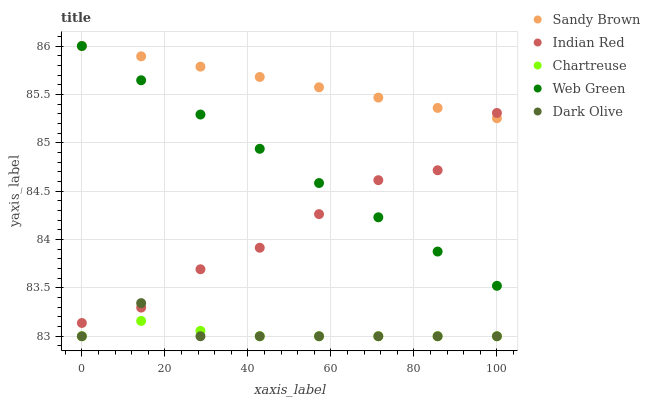Does Chartreuse have the minimum area under the curve?
Answer yes or no. Yes. Does Sandy Brown have the maximum area under the curve?
Answer yes or no. Yes. Does Dark Olive have the minimum area under the curve?
Answer yes or no. No. Does Dark Olive have the maximum area under the curve?
Answer yes or no. No. Is Web Green the smoothest?
Answer yes or no. Yes. Is Indian Red the roughest?
Answer yes or no. Yes. Is Dark Olive the smoothest?
Answer yes or no. No. Is Dark Olive the roughest?
Answer yes or no. No. Does Chartreuse have the lowest value?
Answer yes or no. Yes. Does Sandy Brown have the lowest value?
Answer yes or no. No. Does Web Green have the highest value?
Answer yes or no. Yes. Does Dark Olive have the highest value?
Answer yes or no. No. Is Dark Olive less than Web Green?
Answer yes or no. Yes. Is Sandy Brown greater than Chartreuse?
Answer yes or no. Yes. Does Dark Olive intersect Indian Red?
Answer yes or no. Yes. Is Dark Olive less than Indian Red?
Answer yes or no. No. Is Dark Olive greater than Indian Red?
Answer yes or no. No. Does Dark Olive intersect Web Green?
Answer yes or no. No. 